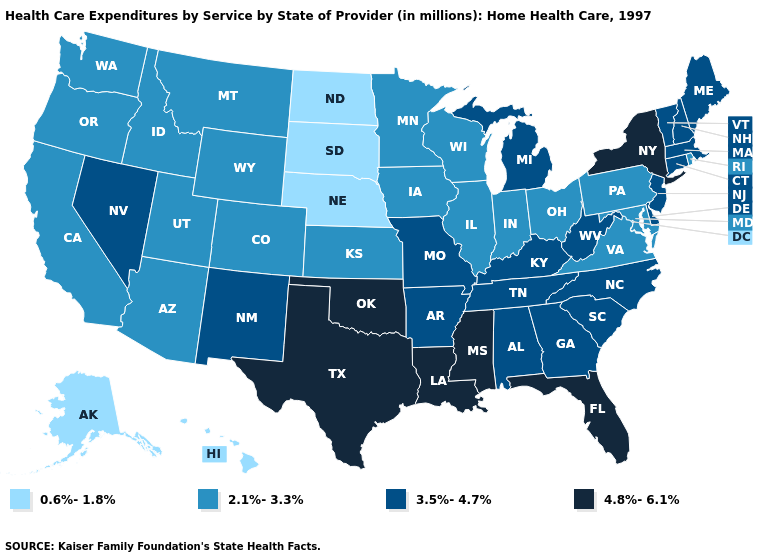Name the states that have a value in the range 4.8%-6.1%?
Give a very brief answer. Florida, Louisiana, Mississippi, New York, Oklahoma, Texas. Which states have the highest value in the USA?
Write a very short answer. Florida, Louisiana, Mississippi, New York, Oklahoma, Texas. Does Arkansas have the same value as Georgia?
Concise answer only. Yes. Name the states that have a value in the range 3.5%-4.7%?
Keep it brief. Alabama, Arkansas, Connecticut, Delaware, Georgia, Kentucky, Maine, Massachusetts, Michigan, Missouri, Nevada, New Hampshire, New Jersey, New Mexico, North Carolina, South Carolina, Tennessee, Vermont, West Virginia. What is the value of Wyoming?
Answer briefly. 2.1%-3.3%. Is the legend a continuous bar?
Answer briefly. No. What is the highest value in states that border Colorado?
Keep it brief. 4.8%-6.1%. Does the first symbol in the legend represent the smallest category?
Keep it brief. Yes. Name the states that have a value in the range 3.5%-4.7%?
Short answer required. Alabama, Arkansas, Connecticut, Delaware, Georgia, Kentucky, Maine, Massachusetts, Michigan, Missouri, Nevada, New Hampshire, New Jersey, New Mexico, North Carolina, South Carolina, Tennessee, Vermont, West Virginia. What is the value of South Carolina?
Short answer required. 3.5%-4.7%. What is the value of Maryland?
Write a very short answer. 2.1%-3.3%. What is the value of New York?
Write a very short answer. 4.8%-6.1%. Does the first symbol in the legend represent the smallest category?
Give a very brief answer. Yes. What is the highest value in states that border Indiana?
Short answer required. 3.5%-4.7%. What is the highest value in states that border Washington?
Concise answer only. 2.1%-3.3%. 